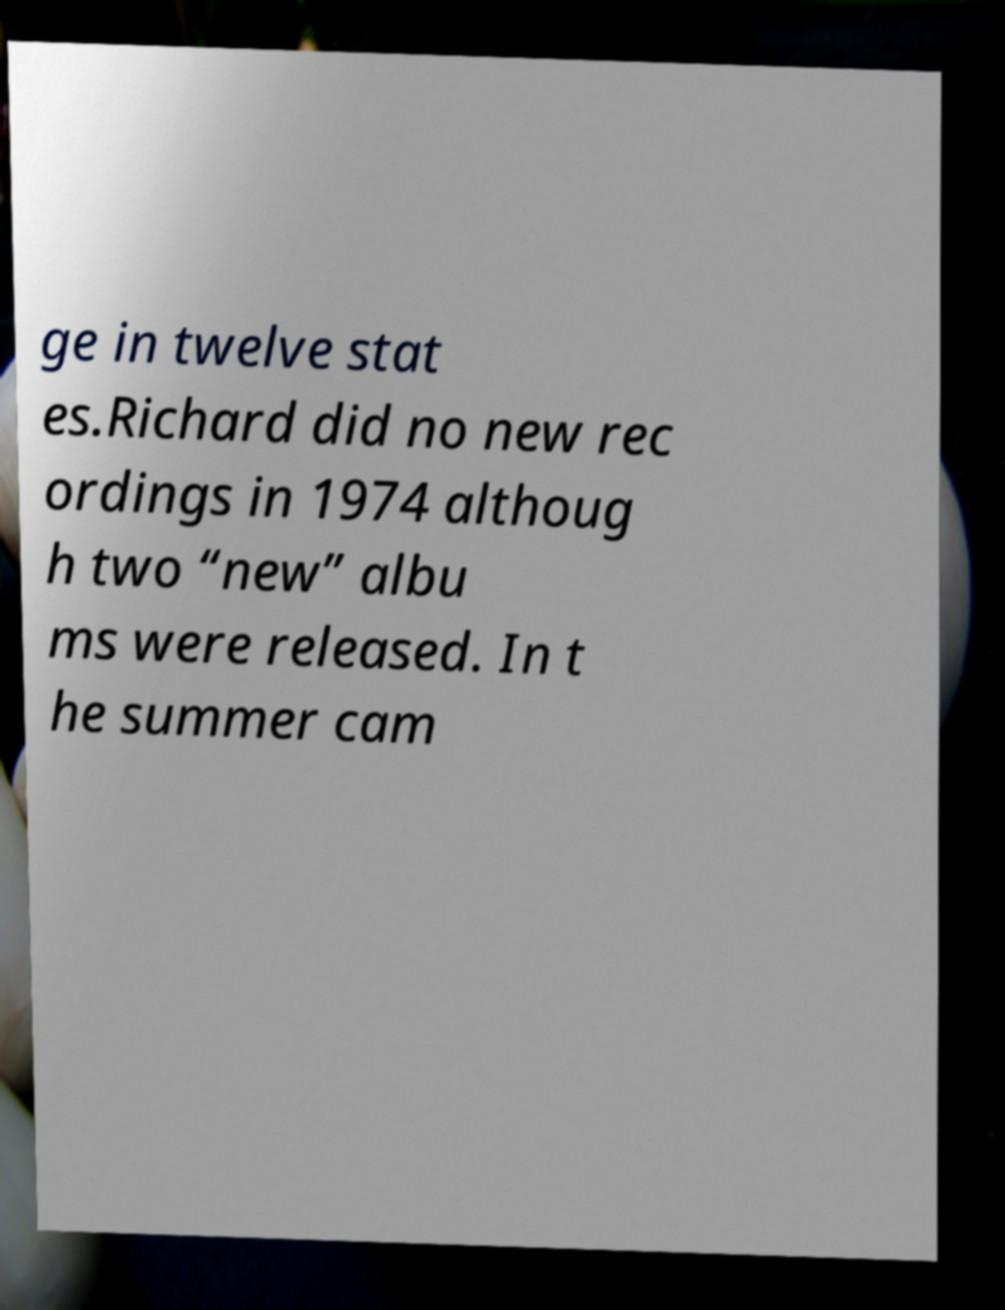Could you extract and type out the text from this image? ge in twelve stat es.Richard did no new rec ordings in 1974 althoug h two “new” albu ms were released. In t he summer cam 